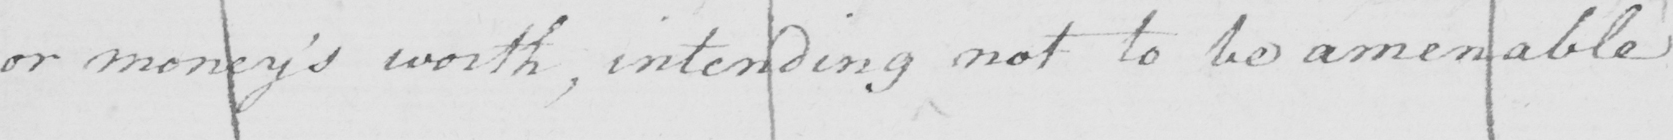Transcribe the text shown in this historical manuscript line. or money ' s worth , intending not to be amenable 